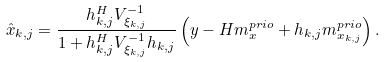Convert formula to latex. <formula><loc_0><loc_0><loc_500><loc_500>\hat { x } _ { k , j } = \frac { h _ { k , j } ^ { H } V _ { \xi _ { k , j } } ^ { - 1 } } { 1 + h _ { k , j } ^ { H } V _ { \xi _ { k , j } } ^ { - 1 } h _ { k , j } } \left ( y - H m _ { x } ^ { p r i o } + h _ { k , j } m _ { x _ { k , j } } ^ { p r i o } \right ) .</formula> 